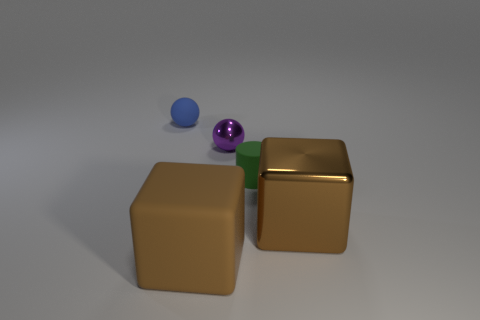How many small red blocks have the same material as the purple thing?
Your answer should be compact. 0. What color is the sphere that is the same material as the tiny green object?
Give a very brief answer. Blue. There is a blue matte object behind the ball in front of the tiny sphere that is on the left side of the purple ball; what size is it?
Ensure brevity in your answer.  Small. Is the number of blue spheres less than the number of big blue cubes?
Offer a very short reply. No. What color is the other large object that is the same shape as the brown matte thing?
Offer a very short reply. Brown. There is a small rubber object in front of the small ball right of the matte ball; are there any rubber cylinders that are to the left of it?
Your response must be concise. No. Is the brown shiny thing the same shape as the blue matte object?
Your answer should be compact. No. Are there fewer small metal spheres on the right side of the cylinder than big purple shiny objects?
Provide a short and direct response. No. There is a big cube that is in front of the big brown thing that is behind the brown block that is to the left of the green rubber thing; what is its color?
Offer a very short reply. Brown. How many rubber things are either green objects or large green balls?
Provide a short and direct response. 1. 